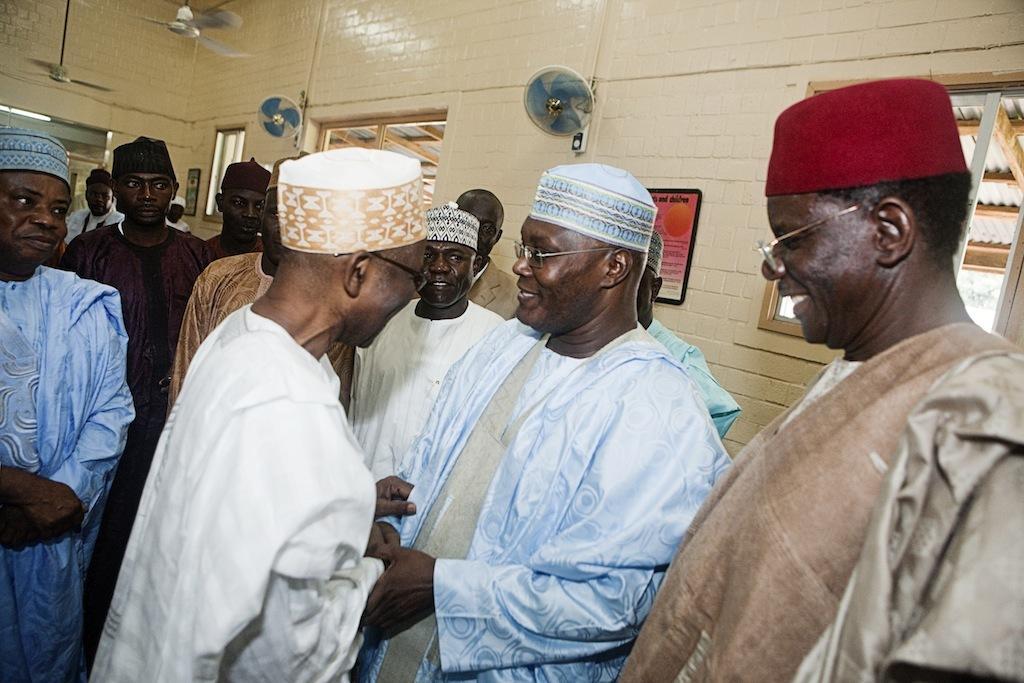Could you give a brief overview of what you see in this image? In this image I can see a group of people. On the right, I can see the window. At the top I can see the fans. 